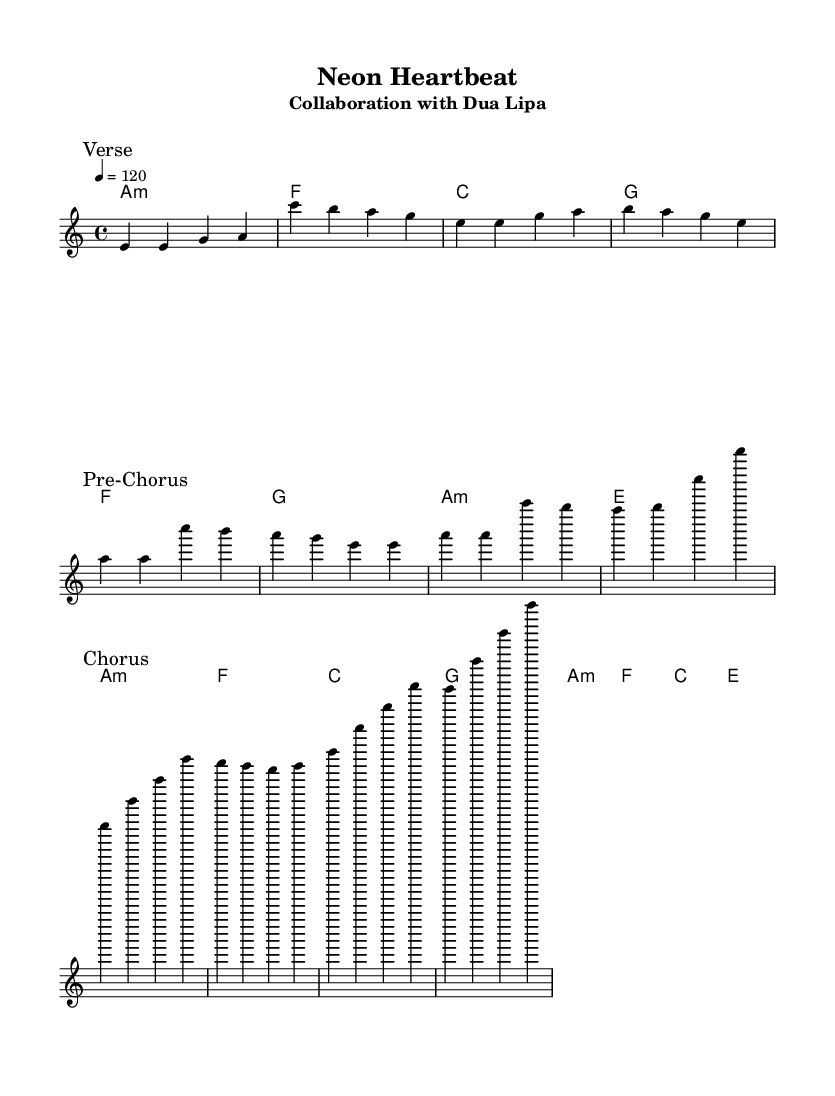What is the key signature of this music? The key signature is A minor, which typically has no sharps or flats, indicated by the "a" in the global section.
Answer: A minor What is the time signature of this music? The time signature is 4/4, which is shown in the global section indicating four beats per measure.
Answer: 4/4 What is the tempo of this music? The tempo is set at 120 beats per minute, indicated by the "4 = 120" marking in the global section.
Answer: 120 How many sections are there in this song? The song contains three distinct sections: Verse, Pre-Chorus, and Chorus, each marked in the melody.
Answer: Three What is the first lyric sung in the Verse? The first lyrics sung in the Verse are "Ne -- on lights flic -- ker in the dark," as detailed in the verseWords section.
Answer: "Ne -- on lights flic -- ker in the dark." Which artist collaborated on this song? The collaboration is noted in the subtitle, which indicates that Dua Lipa is the featured artist on this song.
Answer: Dua Lipa What type of harmonies are indicated at the start of this score? The harmonies indicate that the song begins with an A minor chord, labeled as "a1:m" in the chordmode section.
Answer: A minor 